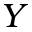Convert formula to latex. <formula><loc_0><loc_0><loc_500><loc_500>Y</formula> 